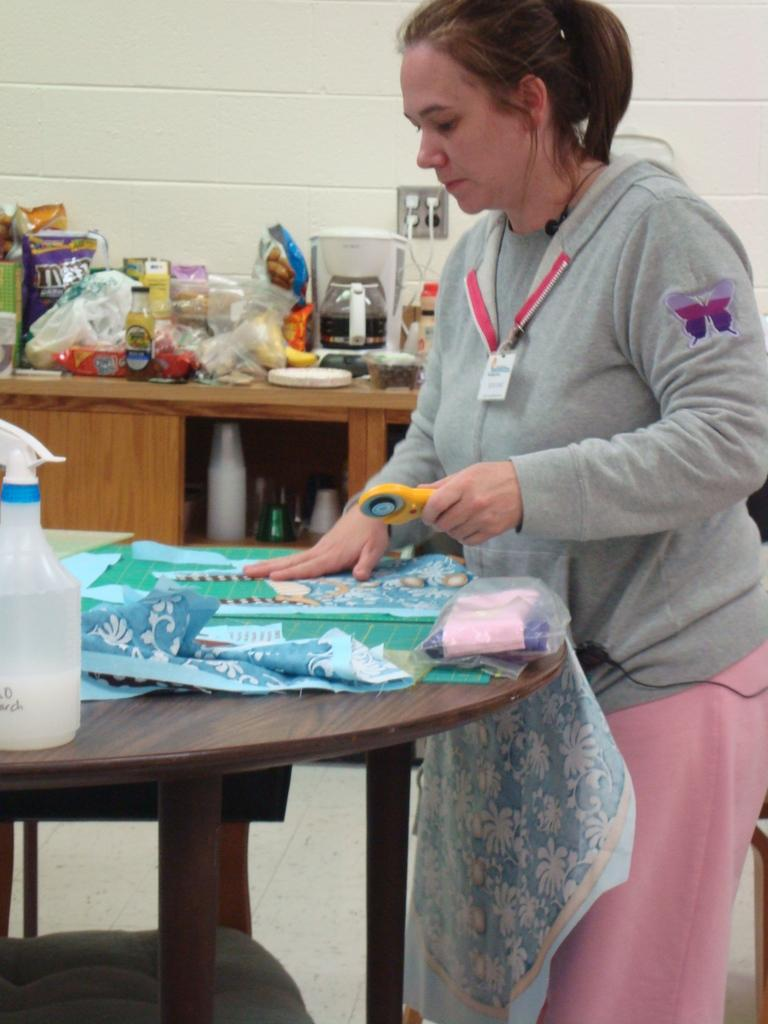What is the position of the person in the image? There is a person standing in front of the table. What is covering the table in the image? There is a cloth on the table. Can you describe the objects on the right side of the person? Unfortunately, the provided facts do not give any information about the objects on the right side of the person. What type of advertisement can be seen on the pizzas in the image? There are no pizzas present in the image, so there cannot be any advertisements on them. 